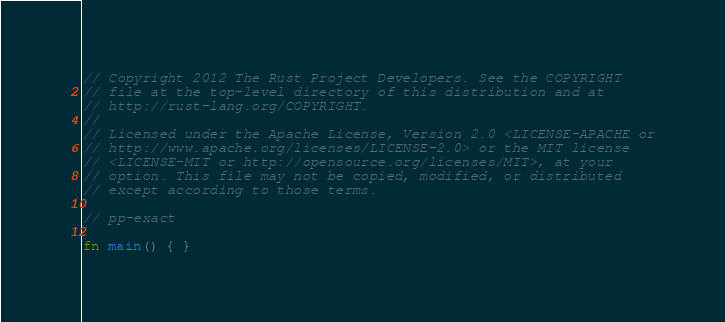Convert code to text. <code><loc_0><loc_0><loc_500><loc_500><_Rust_>// Copyright 2012 The Rust Project Developers. See the COPYRIGHT
// file at the top-level directory of this distribution and at
// http://rust-lang.org/COPYRIGHT.
//
// Licensed under the Apache License, Version 2.0 <LICENSE-APACHE or
// http://www.apache.org/licenses/LICENSE-2.0> or the MIT license
// <LICENSE-MIT or http://opensource.org/licenses/MIT>, at your
// option. This file may not be copied, modified, or distributed
// except according to those terms.

// pp-exact

fn main() { }
</code> 